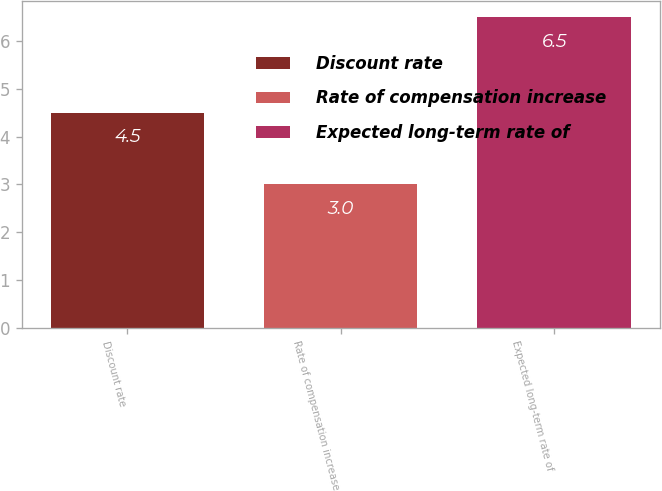<chart> <loc_0><loc_0><loc_500><loc_500><bar_chart><fcel>Discount rate<fcel>Rate of compensation increase<fcel>Expected long-term rate of<nl><fcel>4.5<fcel>3<fcel>6.5<nl></chart> 